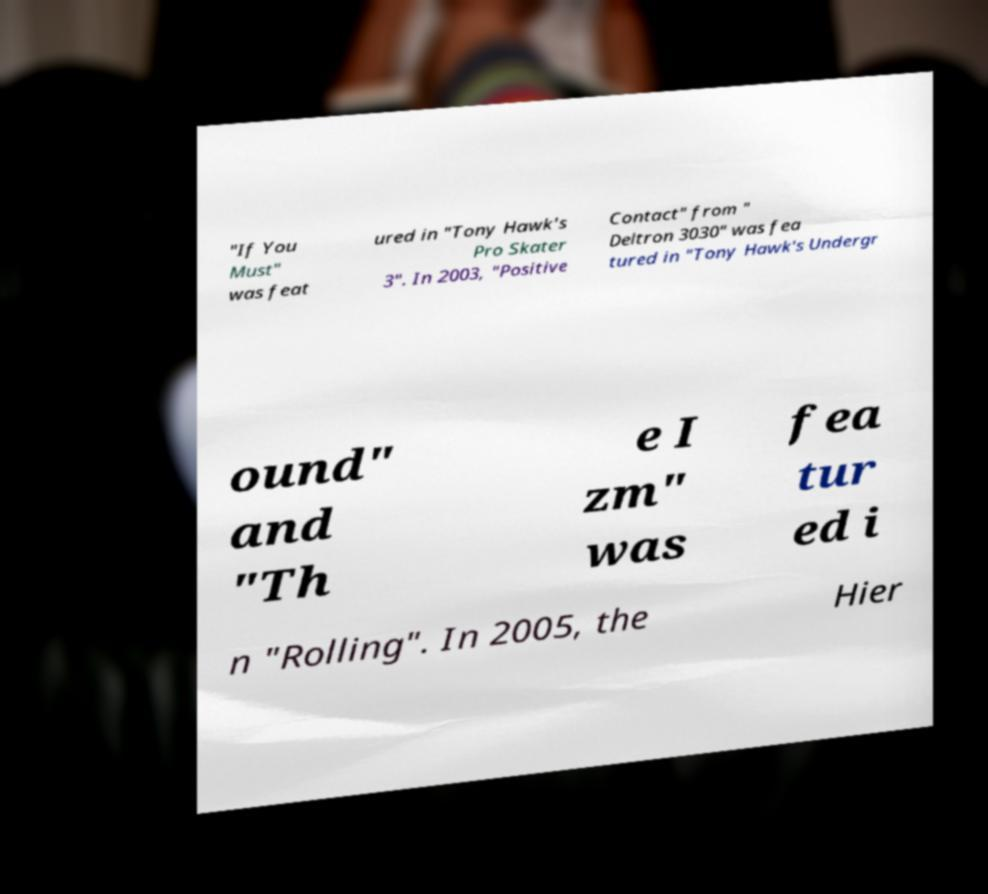Could you extract and type out the text from this image? "If You Must" was feat ured in "Tony Hawk's Pro Skater 3". In 2003, "Positive Contact" from " Deltron 3030" was fea tured in "Tony Hawk's Undergr ound" and "Th e I zm" was fea tur ed i n "Rolling". In 2005, the Hier 